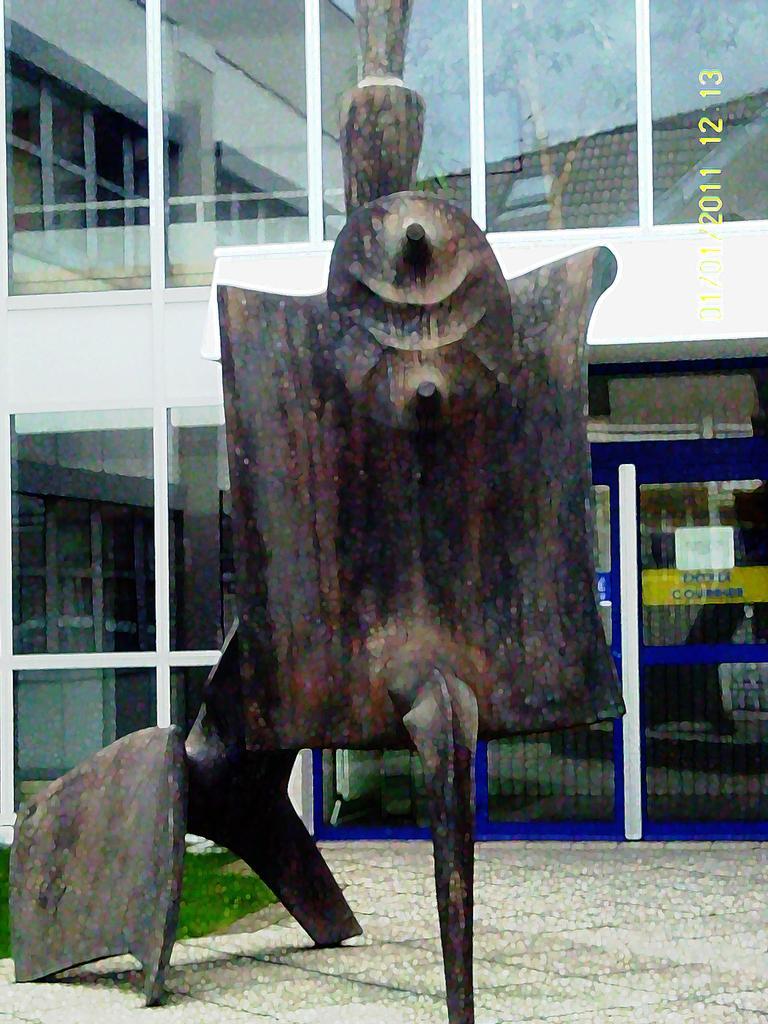Can you describe this image briefly? In this picture I can observe a sculpture on the land. In the background I can observe a building. There is a glass door in the background. 